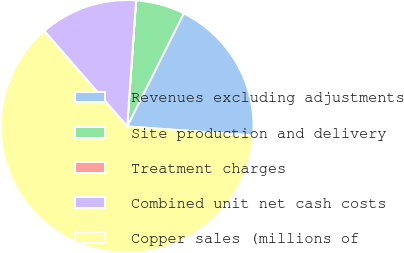<chart> <loc_0><loc_0><loc_500><loc_500><pie_chart><fcel>Revenues excluding adjustments<fcel>Site production and delivery<fcel>Treatment charges<fcel>Combined unit net cash costs<fcel>Copper sales (millions of<nl><fcel>18.75%<fcel>6.26%<fcel>0.01%<fcel>12.5%<fcel>62.48%<nl></chart> 